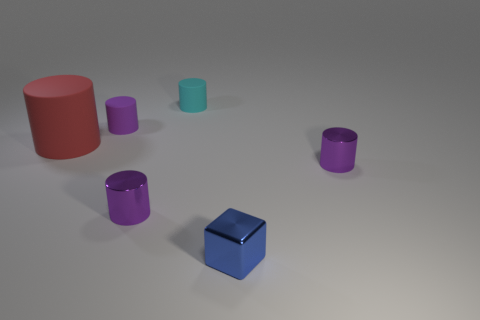Are there any shadows in the image that help determine the light source direction? Yes, the shadows in the image are subtle but they can be seen stretching towards the left, indicating the light source is coming from the right-hand side. Is the surface on which the objects are placed level or at an angle? The surface appears to be level since the shadows cast by the objects are uniform in length and orientation, which typically doesn't happen on an angled surface. 